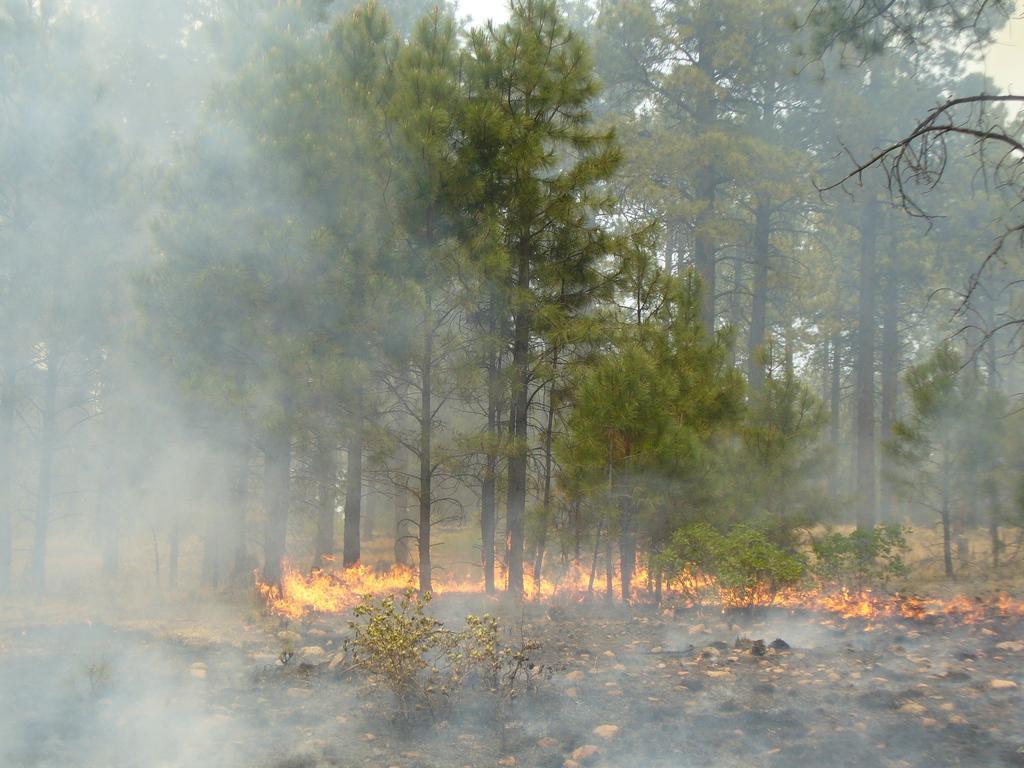Please provide a concise description of this image. In this picture I can see the fire on the ground. In the background I can see many trees, plants and grass. At the bottom I can see many small stones. On the left I can see the smoke. At the top I can see the sky. 